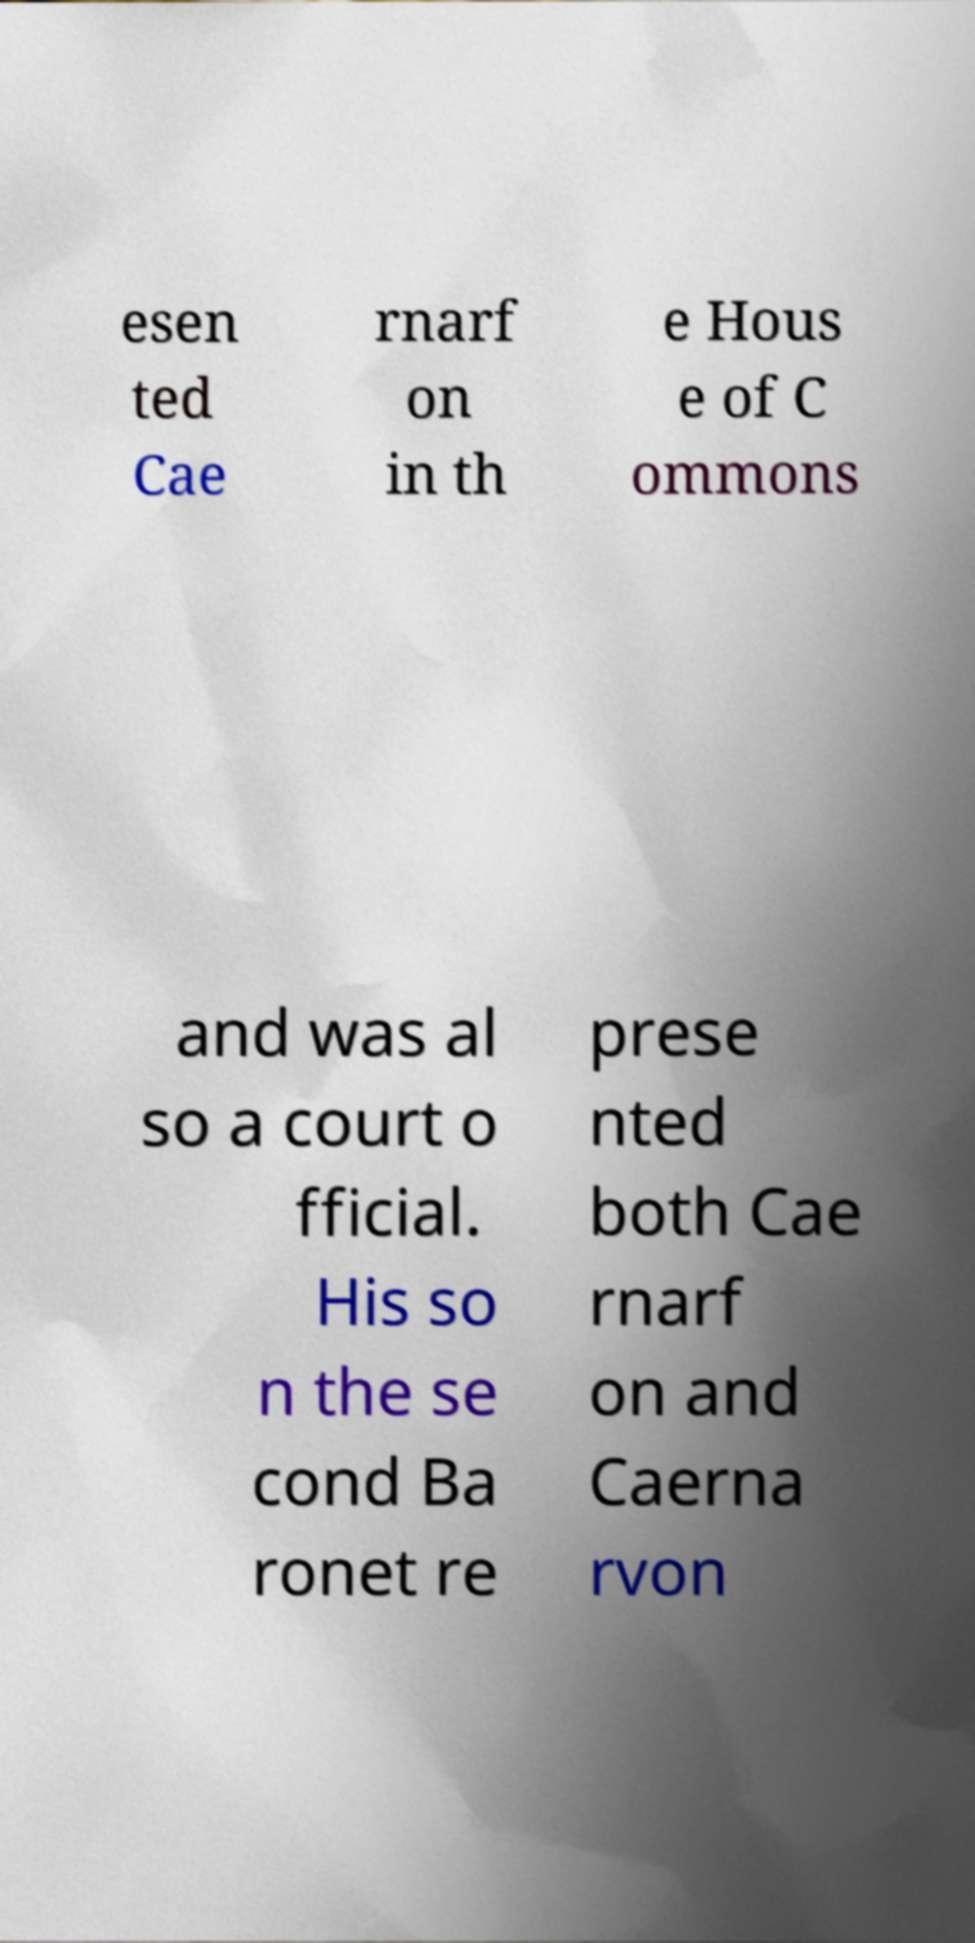Please read and relay the text visible in this image. What does it say? esen ted Cae rnarf on in th e Hous e of C ommons and was al so a court o fficial. His so n the se cond Ba ronet re prese nted both Cae rnarf on and Caerna rvon 